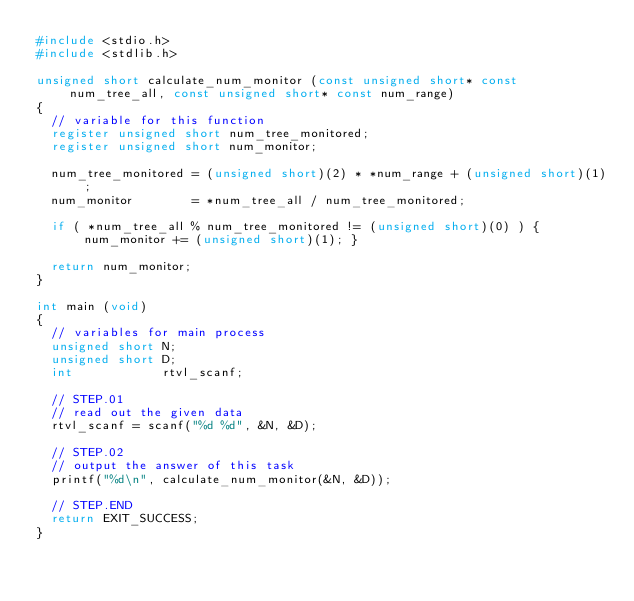<code> <loc_0><loc_0><loc_500><loc_500><_C_>#include <stdio.h>
#include <stdlib.h>

unsigned short calculate_num_monitor (const unsigned short* const num_tree_all, const unsigned short* const num_range)
{
	// variable for this function
	register unsigned short num_tree_monitored;
	register unsigned short num_monitor;

	num_tree_monitored = (unsigned short)(2) * *num_range + (unsigned short)(1);
	num_monitor        = *num_tree_all / num_tree_monitored;

	if ( *num_tree_all % num_tree_monitored != (unsigned short)(0) ) { num_monitor += (unsigned short)(1); }

	return num_monitor;
}

int main (void)
{
	// variables for main process
	unsigned short N;
	unsigned short D;
	int            rtvl_scanf;

	// STEP.01
	// read out the given data
	rtvl_scanf = scanf("%d %d", &N, &D);

	// STEP.02
	// output the answer of this task
	printf("%d\n", calculate_num_monitor(&N, &D));

	// STEP.END
	return EXIT_SUCCESS;
}</code> 